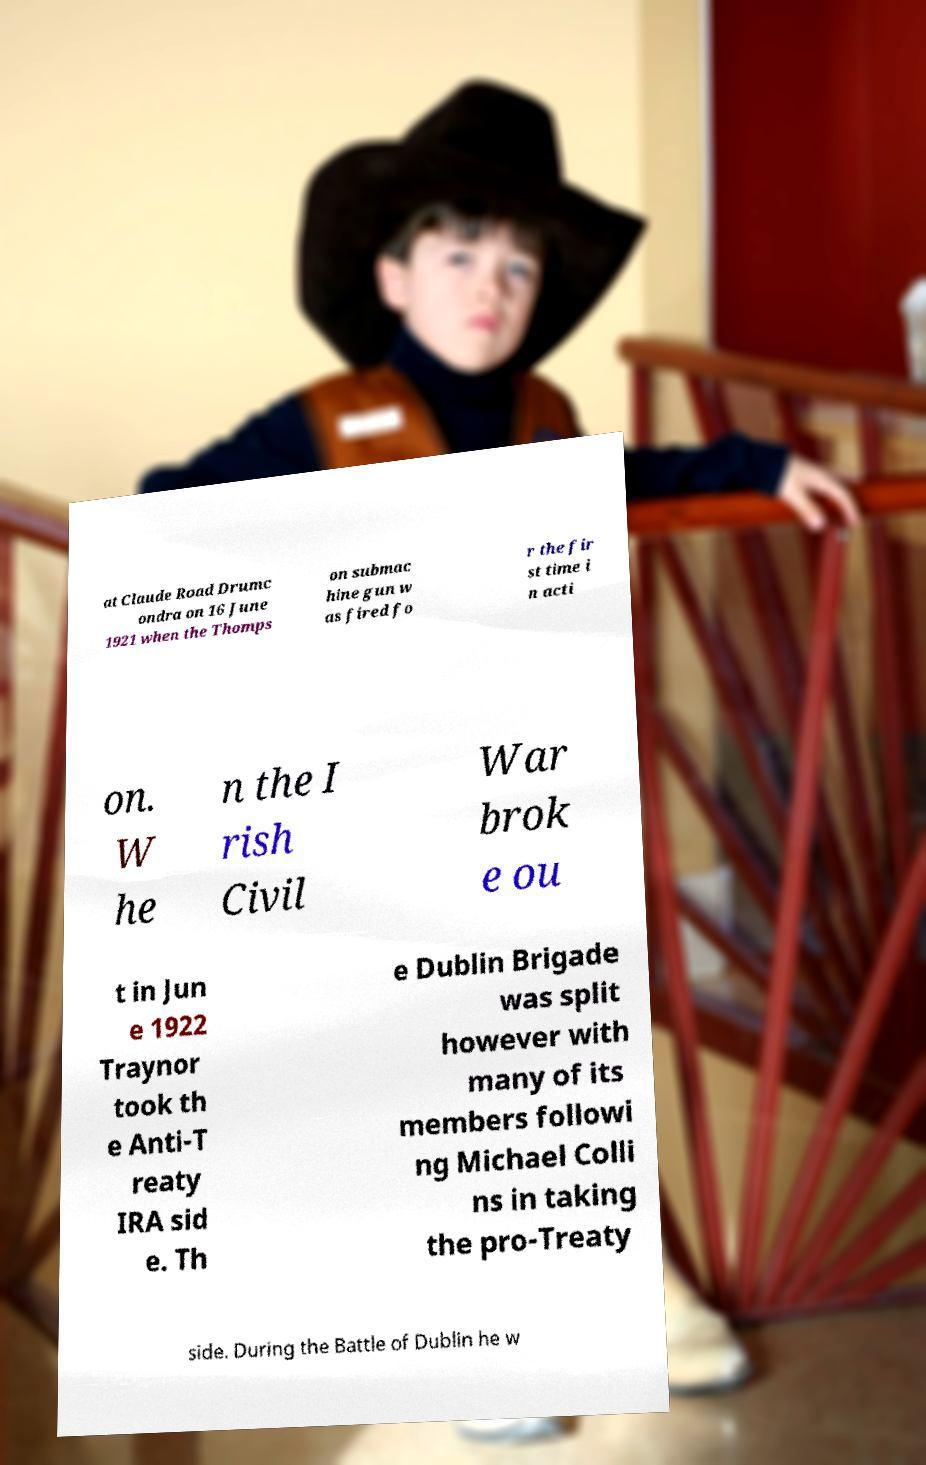Can you accurately transcribe the text from the provided image for me? at Claude Road Drumc ondra on 16 June 1921 when the Thomps on submac hine gun w as fired fo r the fir st time i n acti on. W he n the I rish Civil War brok e ou t in Jun e 1922 Traynor took th e Anti-T reaty IRA sid e. Th e Dublin Brigade was split however with many of its members followi ng Michael Colli ns in taking the pro-Treaty side. During the Battle of Dublin he w 